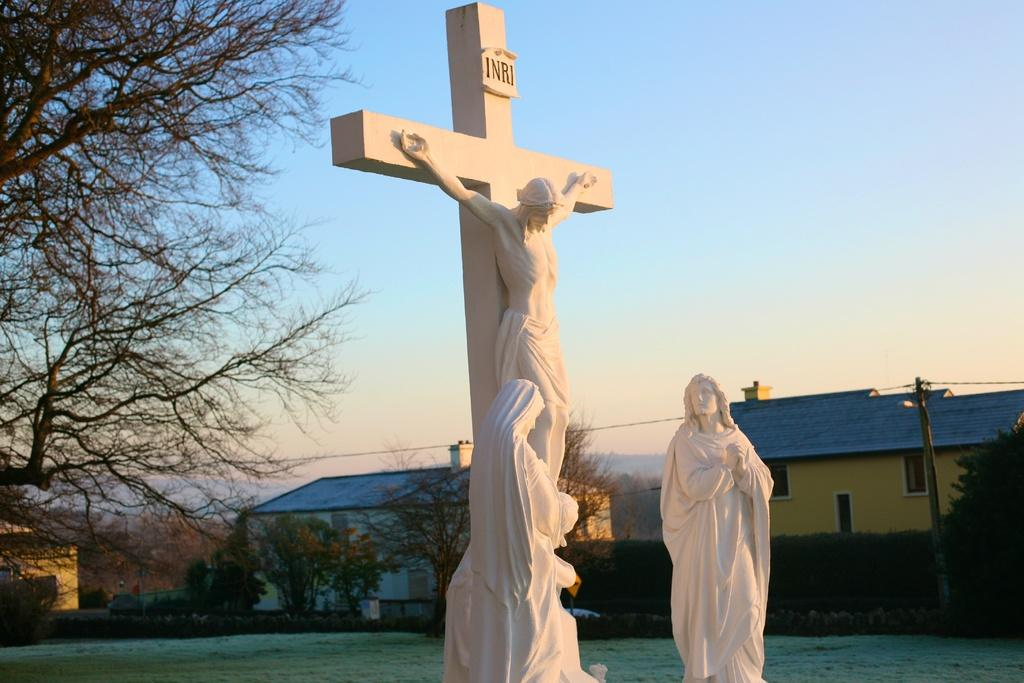<image>
Render a clear and concise summary of the photo. A white cross with Jesus hanging from it and the letters INRI on it. 